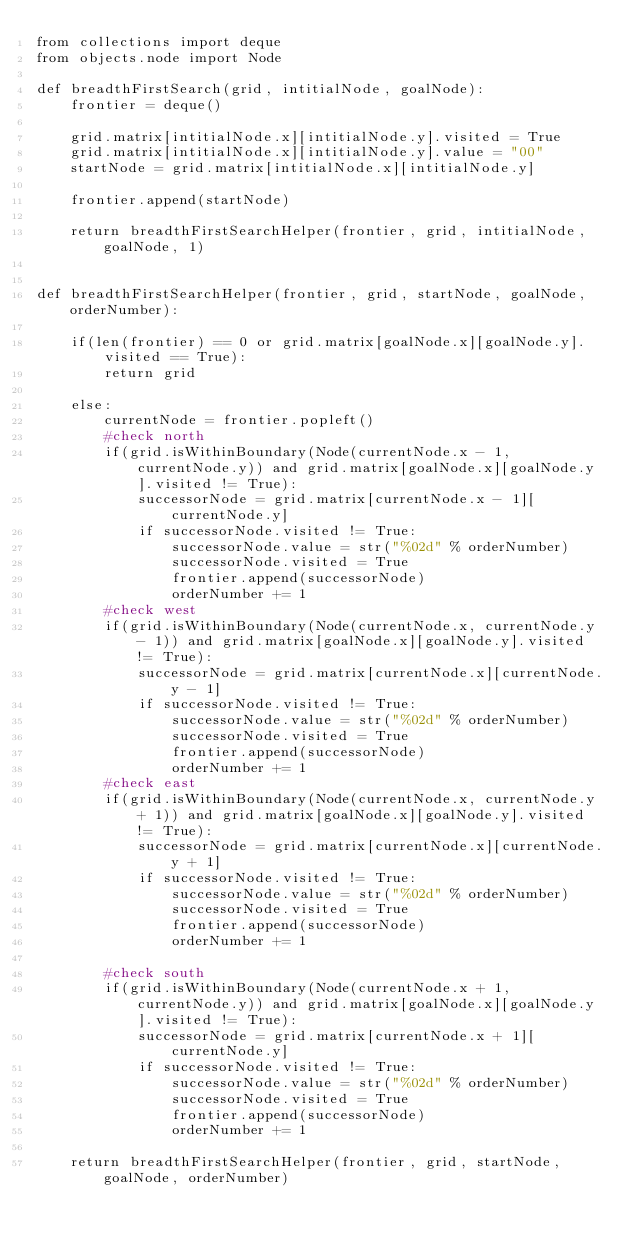<code> <loc_0><loc_0><loc_500><loc_500><_Python_>from collections import deque
from objects.node import Node

def breadthFirstSearch(grid, intitialNode, goalNode):
    frontier = deque()

    grid.matrix[intitialNode.x][intitialNode.y].visited = True
    grid.matrix[intitialNode.x][intitialNode.y].value = "00"
    startNode = grid.matrix[intitialNode.x][intitialNode.y]

    frontier.append(startNode)

    return breadthFirstSearchHelper(frontier, grid, intitialNode, goalNode, 1)


def breadthFirstSearchHelper(frontier, grid, startNode, goalNode, orderNumber):

    if(len(frontier) == 0 or grid.matrix[goalNode.x][goalNode.y].visited == True):
        return grid

    else:    
        currentNode = frontier.popleft()
        #check north
        if(grid.isWithinBoundary(Node(currentNode.x - 1, currentNode.y)) and grid.matrix[goalNode.x][goalNode.y].visited != True):
            successorNode = grid.matrix[currentNode.x - 1][currentNode.y]
            if successorNode.visited != True:
                successorNode.value = str("%02d" % orderNumber)
                successorNode.visited = True
                frontier.append(successorNode)
                orderNumber += 1
        #check west
        if(grid.isWithinBoundary(Node(currentNode.x, currentNode.y - 1)) and grid.matrix[goalNode.x][goalNode.y].visited != True):
            successorNode = grid.matrix[currentNode.x][currentNode.y - 1]
            if successorNode.visited != True:
                successorNode.value = str("%02d" % orderNumber)
                successorNode.visited = True
                frontier.append(successorNode)
                orderNumber += 1
        #check east
        if(grid.isWithinBoundary(Node(currentNode.x, currentNode.y + 1)) and grid.matrix[goalNode.x][goalNode.y].visited != True):
            successorNode = grid.matrix[currentNode.x][currentNode.y + 1]
            if successorNode.visited != True:
                successorNode.value = str("%02d" % orderNumber)
                successorNode.visited = True
                frontier.append(successorNode)
                orderNumber += 1

        #check south
        if(grid.isWithinBoundary(Node(currentNode.x + 1, currentNode.y)) and grid.matrix[goalNode.x][goalNode.y].visited != True):
            successorNode = grid.matrix[currentNode.x + 1][currentNode.y]
            if successorNode.visited != True:
                successorNode.value = str("%02d" % orderNumber)
                successorNode.visited = True
                frontier.append(successorNode)
                orderNumber += 1

    return breadthFirstSearchHelper(frontier, grid, startNode, goalNode, orderNumber)

</code> 